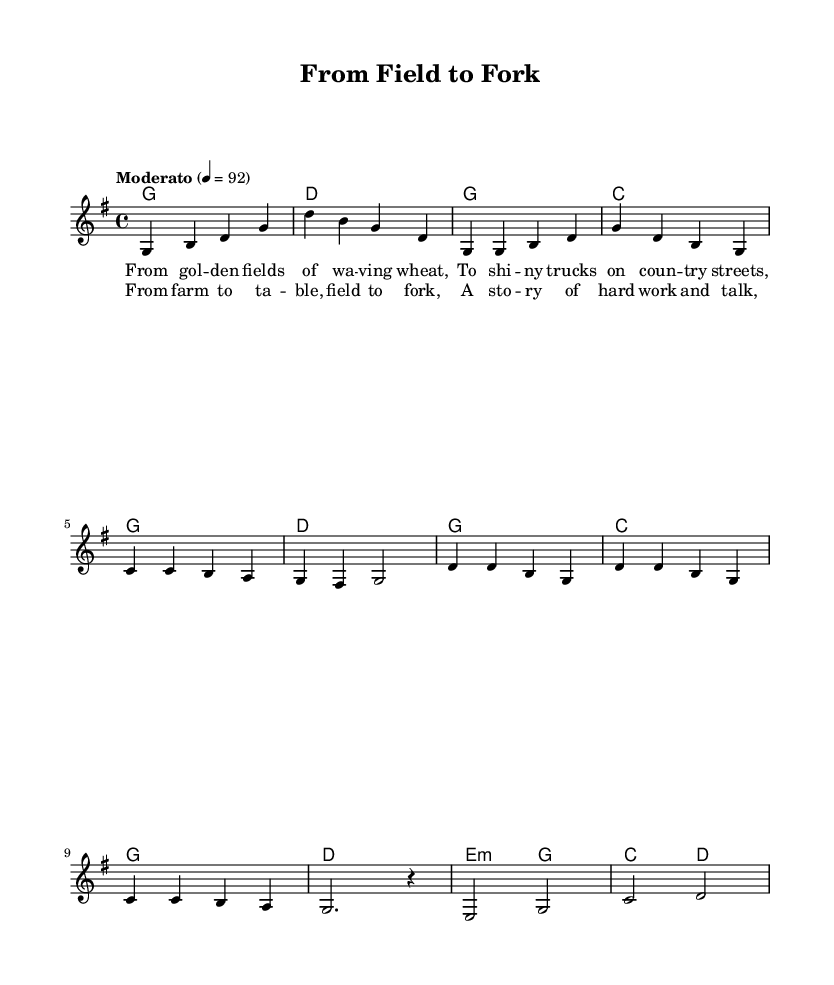What is the key signature of this music? The key signature is G major, which has one sharp (F#). This can be determined by looking at the key signature indicator at the beginning of the sheet music.
Answer: G major What is the time signature of this music? The time signature is 4/4, which indicates there are four beats in a measure and each quarter note gets one beat. This is indicated near the beginning of the score.
Answer: 4/4 What is the tempo marking of this music? The tempo marking is "Moderato," which indicates a moderate pace for the piece. This is found at the start of the score where tempo is indicated.
Answer: Moderato What is the emotional tone conveyed in the chorus lyrics? The emotional tone in the chorus is one of hard work and dedication, reflecting the journey of food from farm to table. This can be inferred from the lyrics describing work and stories associated with farming.
Answer: Hard work How many measures are there in the intro section? There are two measures in the intro section. This can be counted by analyzing the melody line and noting the number of distinct rhythmic groupings or measures present before proceeding to the verse.
Answer: 2 What harmonic progression is used in the chorus? The harmonic progression in the chorus is G - C - G - D. This is identified by examining the chord changes specified in the harmonies section and correlating them with the corresponding lyrics.
Answer: G - C - G - D What narrative theme does the song explore? The theme explored in the song is the journey of food from farm to table. This can be inferred from both the title and the content of the lyrics, which focus on farming and the subsequent process of getting food to consumers.
Answer: Journey of food 